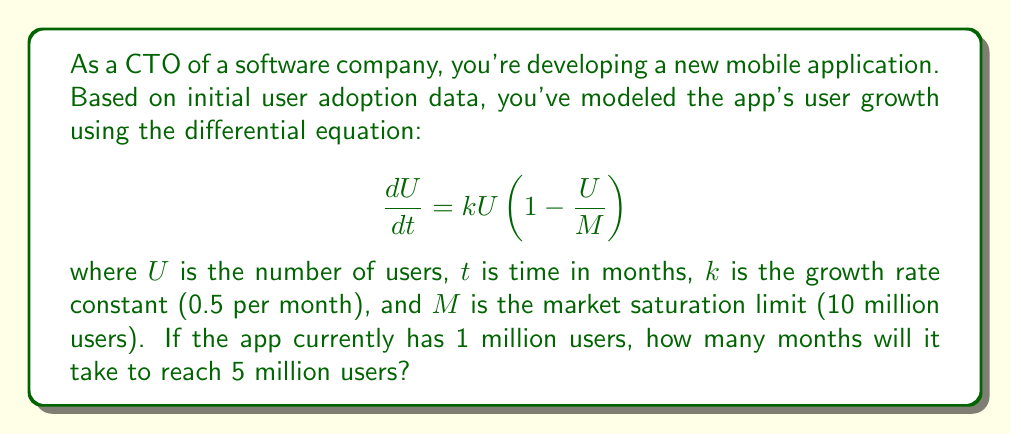Can you solve this math problem? To solve this problem, we'll use the logistic growth model, which is described by the given differential equation. The solution to this equation is:

$$U(t) = \frac{M}{1 + (\frac{M}{U_0} - 1)e^{-kt}}$$

Where $U_0$ is the initial number of users.

Given:
- $M = 10$ million users
- $k = 0.5$ per month
- $U_0 = 1$ million users
- We want to find $t$ when $U(t) = 5$ million users

Step 1: Substitute the known values into the equation:

$$5 = \frac{10}{1 + (\frac{10}{1} - 1)e^{-0.5t}}$$

Step 2: Simplify:

$$5 = \frac{10}{1 + 9e^{-0.5t}}$$

Step 3: Multiply both sides by the denominator:

$$5(1 + 9e^{-0.5t}) = 10$$

Step 4: Distribute on the left side:

$$5 + 45e^{-0.5t} = 10$$

Step 5: Subtract 5 from both sides:

$$45e^{-0.5t} = 5$$

Step 6: Divide both sides by 45:

$$e^{-0.5t} = \frac{1}{9}$$

Step 7: Take the natural log of both sides:

$$-0.5t = \ln(\frac{1}{9})$$

Step 8: Solve for t:

$$t = -\frac{2}{0.5}\ln(\frac{1}{9}) \approx 8.78$$

Therefore, it will take approximately 8.78 months to reach 5 million users.
Answer: 8.78 months 